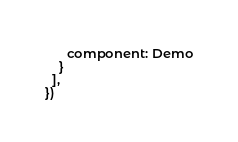<code> <loc_0><loc_0><loc_500><loc_500><_JavaScript_>      component: Demo
    }
  ],
})
</code> 